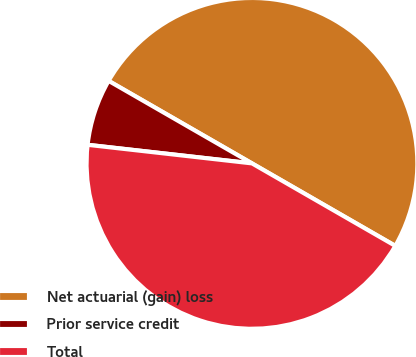<chart> <loc_0><loc_0><loc_500><loc_500><pie_chart><fcel>Net actuarial (gain) loss<fcel>Prior service credit<fcel>Total<nl><fcel>50.0%<fcel>6.52%<fcel>43.48%<nl></chart> 